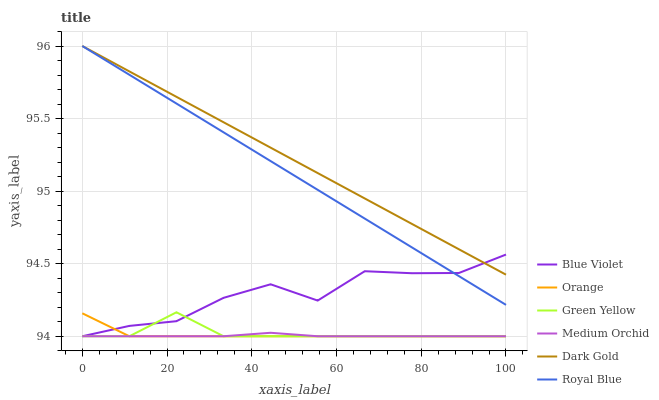Does Medium Orchid have the minimum area under the curve?
Answer yes or no. Yes. Does Dark Gold have the maximum area under the curve?
Answer yes or no. Yes. Does Royal Blue have the minimum area under the curve?
Answer yes or no. No. Does Royal Blue have the maximum area under the curve?
Answer yes or no. No. Is Dark Gold the smoothest?
Answer yes or no. Yes. Is Blue Violet the roughest?
Answer yes or no. Yes. Is Medium Orchid the smoothest?
Answer yes or no. No. Is Medium Orchid the roughest?
Answer yes or no. No. Does Royal Blue have the lowest value?
Answer yes or no. No. Does Royal Blue have the highest value?
Answer yes or no. Yes. Does Medium Orchid have the highest value?
Answer yes or no. No. Is Medium Orchid less than Royal Blue?
Answer yes or no. Yes. Is Dark Gold greater than Medium Orchid?
Answer yes or no. Yes. Does Blue Violet intersect Orange?
Answer yes or no. Yes. Is Blue Violet less than Orange?
Answer yes or no. No. Is Blue Violet greater than Orange?
Answer yes or no. No. Does Medium Orchid intersect Royal Blue?
Answer yes or no. No. 